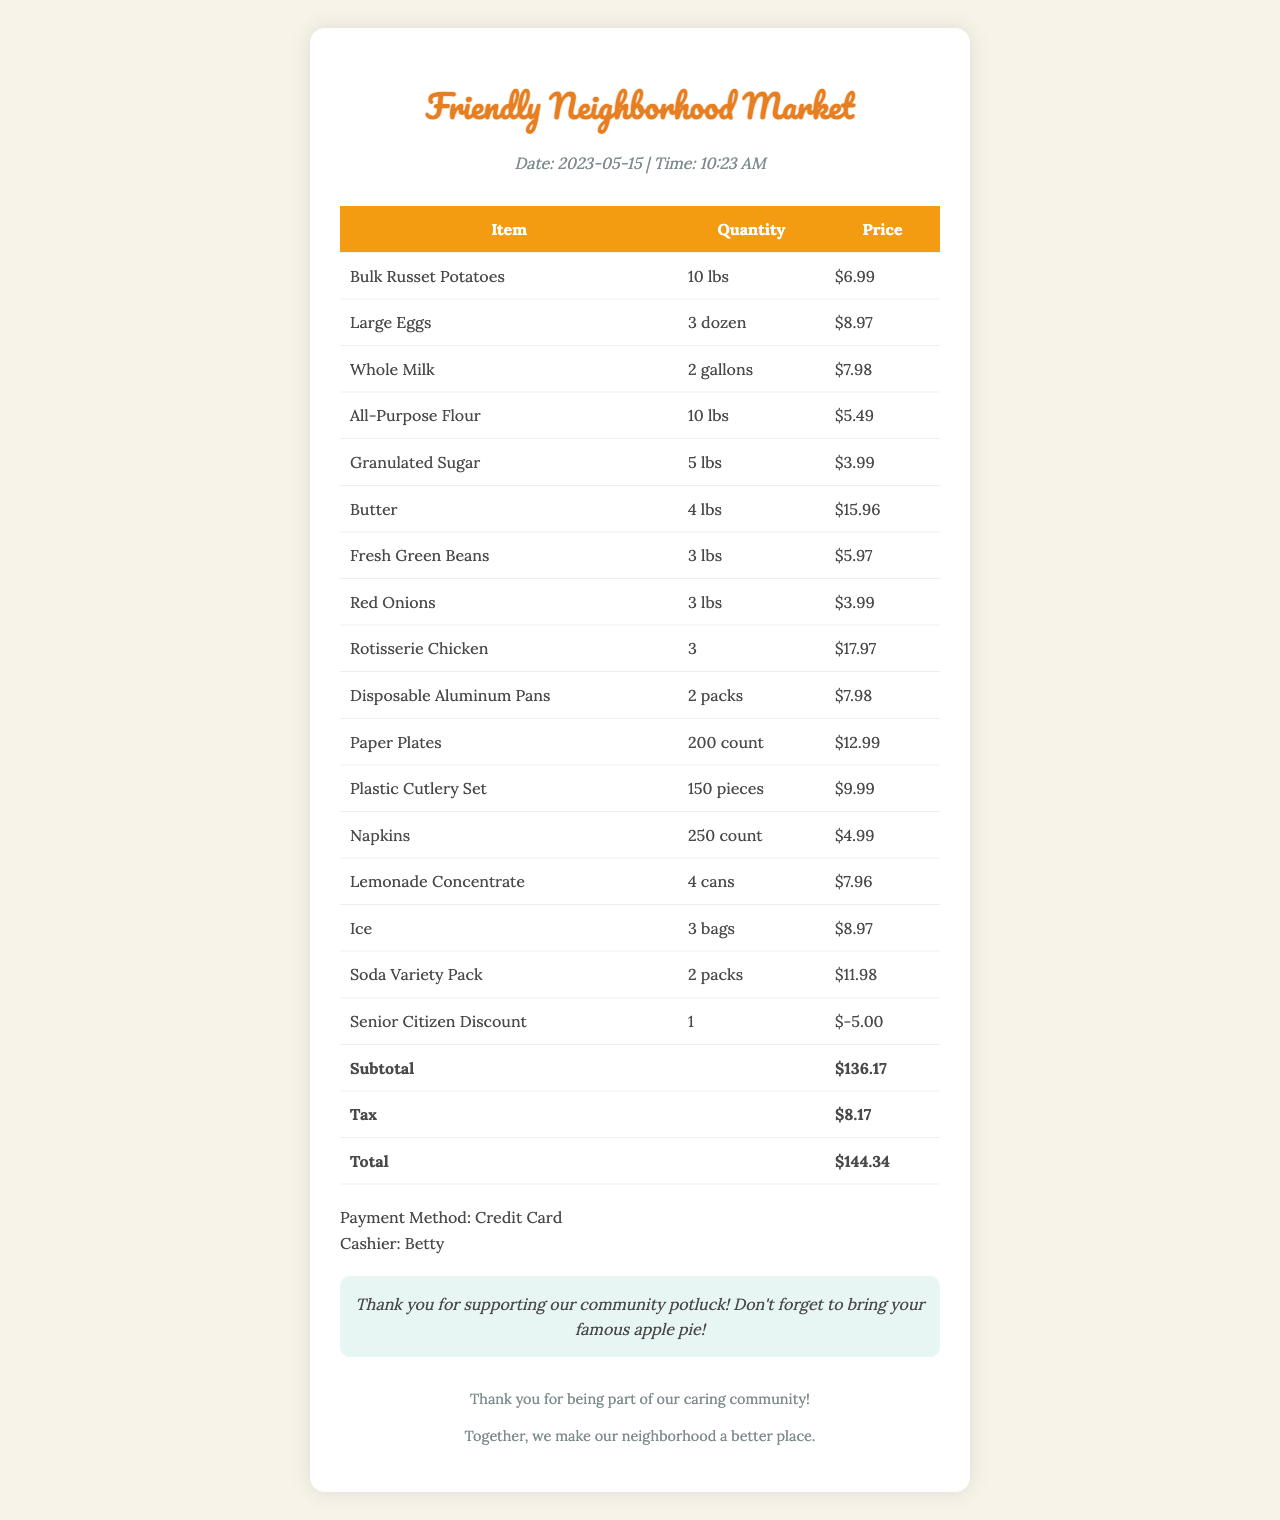What is the store name? The store name is prominently displayed at the top of the document.
Answer: Friendly Neighborhood Market What is the date of the purchase? The date can be found in the header section of the document.
Answer: 2023-05-15 How many gallons of milk were purchased? The quantity of milk is listed among the items in the document.
Answer: 2 gallons What is the price of the disposable aluminum pans? The price of each item is provided in the price column of the receipt.
Answer: 7.98 What was the subtotal amount? The subtotal is clearly stated in the table before tax and total.
Answer: 136.17 Who was the cashier? The cashier's name is mentioned towards the end of the document.
Answer: Betty How many packs of soda were bought? The number of packs is specified in the item list section.
Answer: 2 packs How much was deducted for the senior citizen discount? The discount amount is explicitly mentioned in the items list as a line item.
Answer: 5.00 What is the total amount after tax? The total amount is provided at the bottom of the table and includes tax.
Answer: 144.34 